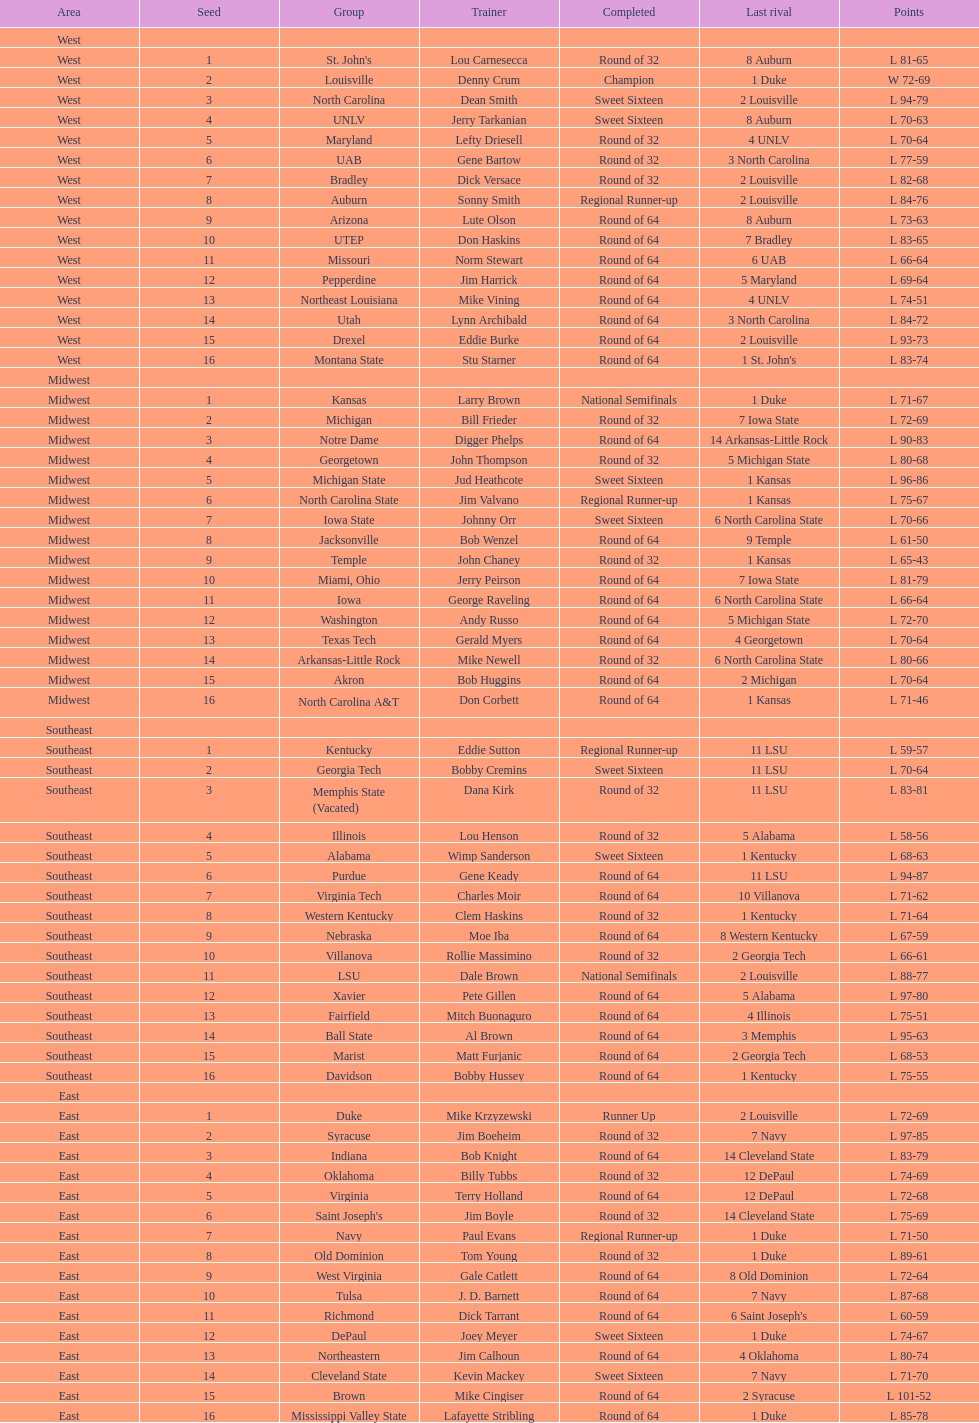Who was the only champion? Louisville. 